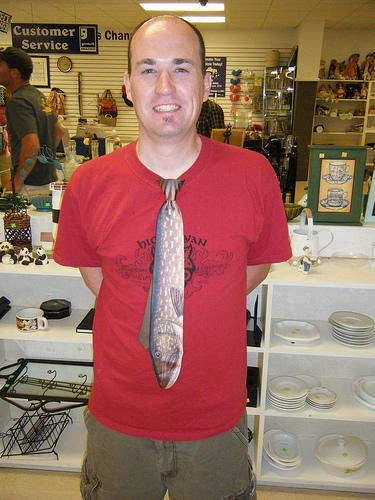Analyze the possible interactions between the man and the objects around him. The man may be shopping for various items, such as ceramicware, dolls, or dishes, and is potentially interacting with the store staff, as there is a customer service sign. Count the total number of plates mentioned in the image description. There are ten plates mentioned in the image description. Assess the quality of the objects being sold in the shop. The objects in the shop appear to be of good quality. They include ceramicware, decorative cups, vegetable steamers, purses, dolls, and dishes on nicely organized shelves. How does the man in the image look and what is he wearing? The man is bald, smiling, wearing a red t-shirt, and a fish tie. What type of store or shop does the image take place in, and what items are for sale? The image takes place in a shop selling ceramicware, decorative cups, vegetable steamers, purses, dolls, watering cans, and dishes on shelves. Identify the type of tie the man is wearing and describe its appearance. The man is wearing a fish-themed necktie that resembles a dead fish. List a few items that can be found on the shelves in the shop. Dishes, white plates, ceramic pandas, and coffee mugs can be found on the shelves in the shop. What type of shirt is the man wearing and what is its color? The man is wearing a red cotton t-shirt. What emotions or feelings does the image convey? The image conveys feelings of happiness, amusement, and casual shopping atmosphere. What can you tell me about the sign in the shop pertaining to customer service? There is a customer service sign in the shop with white lettering on a black background. What is the main object for sale in the shop? Ceramicware. Identify the type of accessory the man is wearing around his neck. A fish theme neck tie. Are there any objects in the image that seem out of place or do not belong in a shop setting? No, all objects seem appropriate for a shop setting. Rate the image quality on a scale of 1 to 5, with 5 being the best quality. 4. What type of rack is on the bottom shelf of the image? Wire rack. Describe the appearance of the tie that the man is wearing. The tie looks like a dead fish. What is the color of the lettering on the customer service sign? White lettering on a black sign. Identify the object referred to in the phrase "this is a plate". White plate on a shelf. What is the color and print of the man's necktie? The necktie has a fish print and is multicolored. What is the color of the shirt the man is wearing? Red. Analyze the interaction between the man and his surroundings. The man is wearing a fish tie and standing in a store. Which caption best describes the man's appearance? A) Man wearing a fish tie with a smile B) Man wearing blue pants and fish tie C) Man with long hair and smiling A) Man wearing a fish tie with a smile. Read any text visible in the image. Customer service sign. What type of animal figures are on the shelf? Ceramic pandas. Identify any unusual objects or occurrences in the image. The fish tie on the man is quite unusual. For each visible plate in the image, identify whether it is in a top, middle or bottom shelf. White plates on middle and top shelf. Choose the correct answer to the question: What is the theme of the man's necktie? A) Fish B) Dogs C) Cars A) Fish. State the color and condition of the man's hair. The man is bald and smiling. List the attributes of the coffee mug on the shelf. Decorative, art on a plaque, ceramic. 